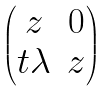<formula> <loc_0><loc_0><loc_500><loc_500>\begin{pmatrix} z & 0 \\ t \lambda & z \end{pmatrix}</formula> 